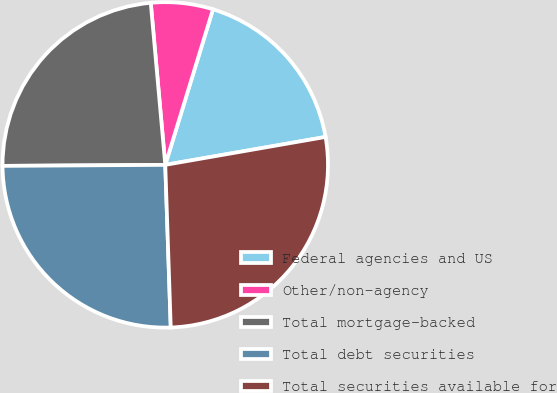<chart> <loc_0><loc_0><loc_500><loc_500><pie_chart><fcel>Federal agencies and US<fcel>Other/non-agency<fcel>Total mortgage-backed<fcel>Total debt securities<fcel>Total securities available for<nl><fcel>17.52%<fcel>6.16%<fcel>23.68%<fcel>25.44%<fcel>27.21%<nl></chart> 